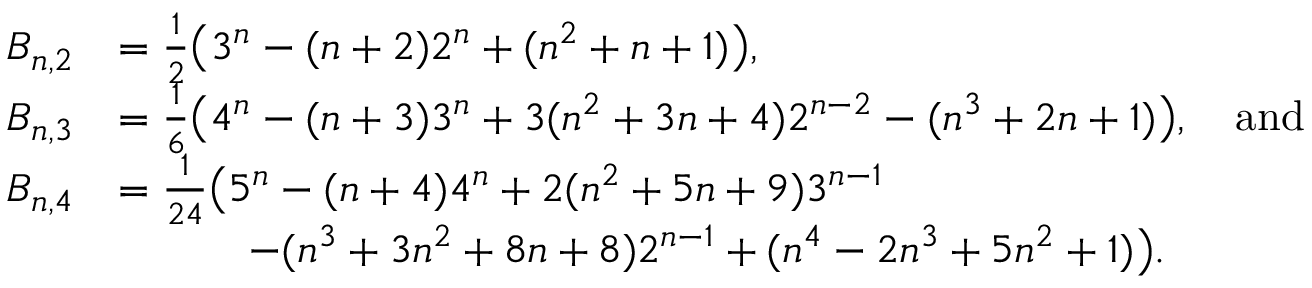Convert formula to latex. <formula><loc_0><loc_0><loc_500><loc_500>\begin{array} { r l } { B _ { n , 2 } } & { = \frac { 1 } { 2 } \left ( 3 ^ { n } - ( n + 2 ) 2 ^ { n } + ( n ^ { 2 } + n + 1 ) \right ) , } \\ { B _ { n , 3 } } & { = \frac { 1 } { 6 } \left ( 4 ^ { n } - ( n + 3 ) 3 ^ { n } + 3 ( n ^ { 2 } + 3 n + 4 ) 2 ^ { n - 2 } - ( n ^ { 3 } + 2 n + 1 ) \right ) , \quad a n d } \\ { B _ { n , 4 } } & { = \frac { 1 } { 2 4 } \left ( 5 ^ { n } - ( n + 4 ) 4 ^ { n } + 2 ( n ^ { 2 } + 5 n + 9 ) 3 ^ { n - 1 } } \\ & { \quad - ( n ^ { 3 } + 3 n ^ { 2 } + 8 n + 8 ) 2 ^ { n - 1 } + ( n ^ { 4 } - 2 n ^ { 3 } + 5 n ^ { 2 } + 1 ) \right ) . } \end{array}</formula> 